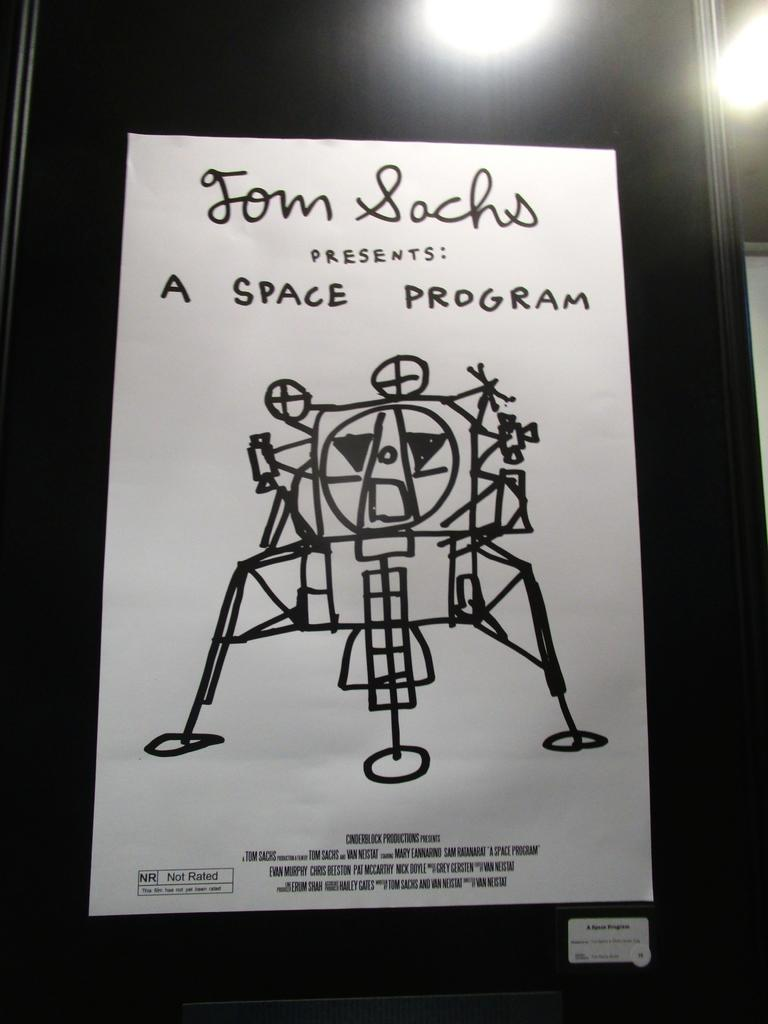<image>
Render a clear and concise summary of the photo. A black and white movie poster with a hand drawn spaceship. It says "Tom Sachs presents: A Space Program." 